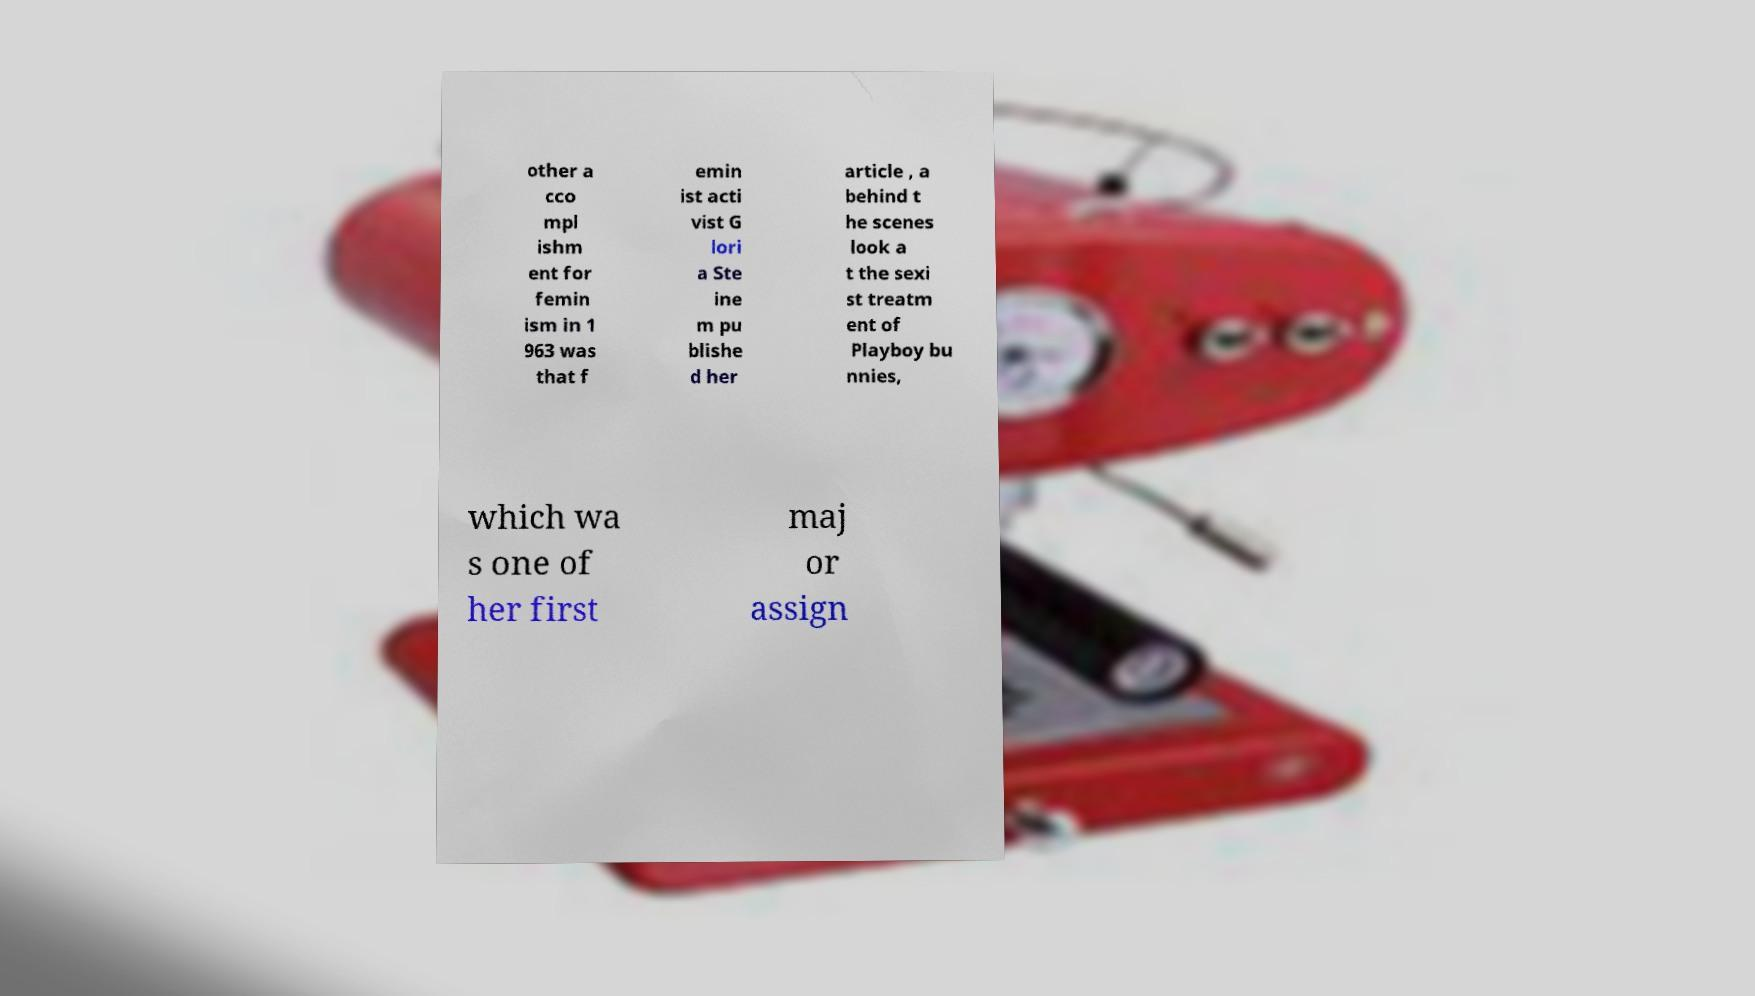Please identify and transcribe the text found in this image. other a cco mpl ishm ent for femin ism in 1 963 was that f emin ist acti vist G lori a Ste ine m pu blishe d her article , a behind t he scenes look a t the sexi st treatm ent of Playboy bu nnies, which wa s one of her first maj or assign 